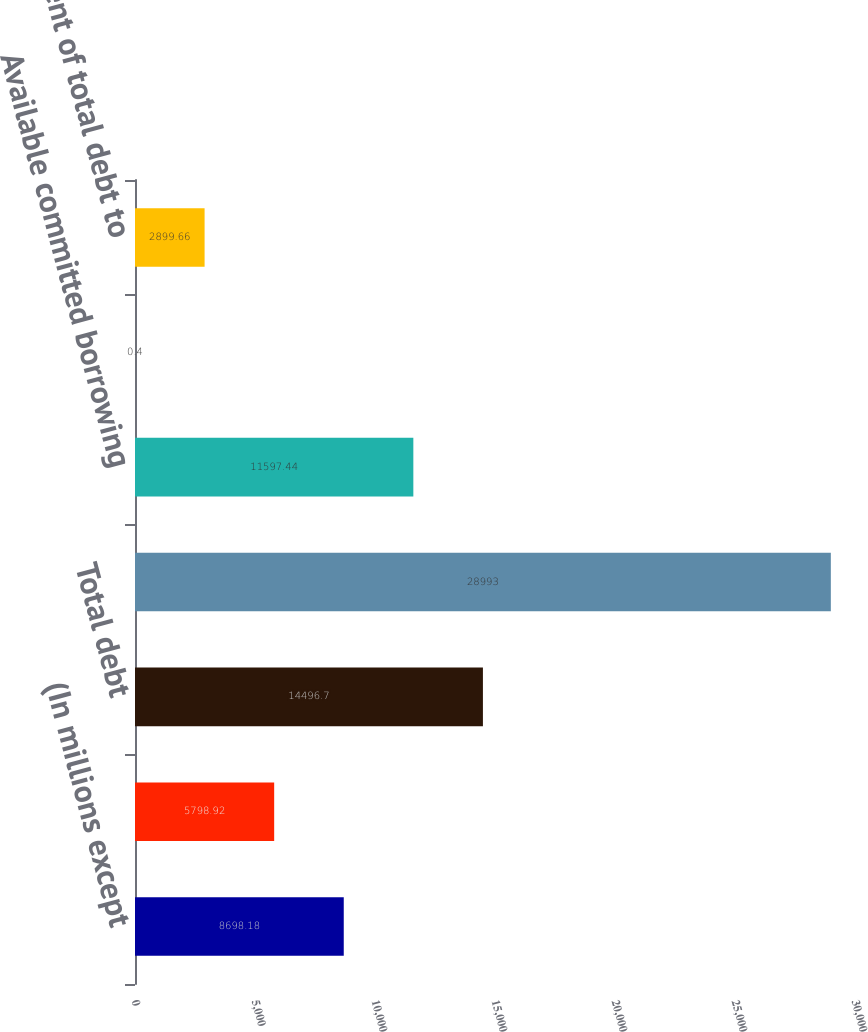<chart> <loc_0><loc_0><loc_500><loc_500><bar_chart><fcel>(In millions except<fcel>Cash and cash equivalents<fcel>Total debt<fcel>Shareholders' equity<fcel>Available committed borrowing<fcel>Floating-rate debt/total debt<fcel>Percent of total debt to<nl><fcel>8698.18<fcel>5798.92<fcel>14496.7<fcel>28993<fcel>11597.4<fcel>0.4<fcel>2899.66<nl></chart> 